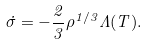<formula> <loc_0><loc_0><loc_500><loc_500>\dot { \sigma } = - \frac { 2 } { 3 } \rho ^ { 1 / 3 } \Lambda ( T ) .</formula> 